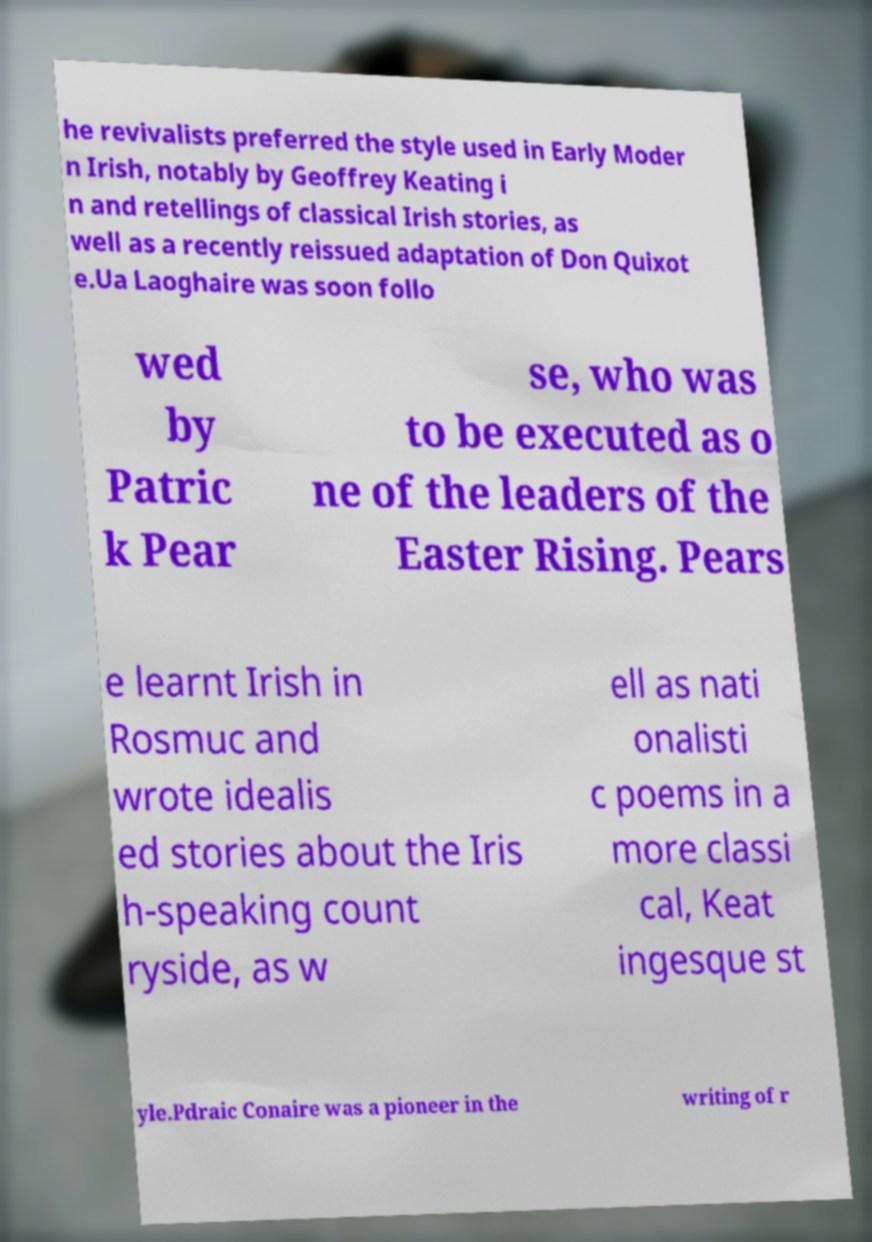Please identify and transcribe the text found in this image. he revivalists preferred the style used in Early Moder n Irish, notably by Geoffrey Keating i n and retellings of classical Irish stories, as well as a recently reissued adaptation of Don Quixot e.Ua Laoghaire was soon follo wed by Patric k Pear se, who was to be executed as o ne of the leaders of the Easter Rising. Pears e learnt Irish in Rosmuc and wrote idealis ed stories about the Iris h-speaking count ryside, as w ell as nati onalisti c poems in a more classi cal, Keat ingesque st yle.Pdraic Conaire was a pioneer in the writing of r 